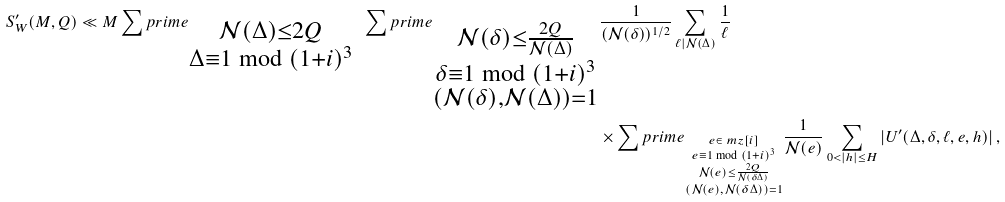Convert formula to latex. <formula><loc_0><loc_0><loc_500><loc_500>S ^ { \prime } _ { W } ( M , Q ) \ll M \sum p r i m e _ { \substack { \mathcal { N } ( \Delta ) \leq 2 Q \\ \Delta \equiv 1 \bmod { ( 1 + i ) ^ { 3 } } } } \ \sum p r i m e _ { \substack { \mathcal { N } ( \delta ) \leq \frac { 2 Q } { \mathcal { N } ( \Delta ) } \\ \delta \equiv 1 \bmod { ( 1 + i ) ^ { 3 } } \\ ( \mathcal { N } ( \delta ) , \mathcal { N } ( \Delta ) ) = 1 } } & \frac { 1 } { ( \mathcal { N } ( \delta ) ) ^ { 1 / 2 } } \sum _ { \ell | \mathcal { N } ( \Delta ) } \frac { 1 } { \ell } \\ & \times \sum p r i m e _ { \substack { e \in \ m z [ i ] \\ e \equiv 1 \bmod { ( 1 + i ) ^ { 3 } } \\ \mathcal { N } ( e ) \leq \frac { 2 Q } { \mathcal { N } ( \delta \Delta ) } \\ ( \mathcal { N } ( e ) , \mathcal { N } ( \delta \Delta ) ) = 1 } } \frac { 1 } { \mathcal { N } ( e ) } \sum _ { 0 < | h | \leq H } \left | U ^ { \prime } ( \Delta , \delta , \ell , e , h ) \right | ,</formula> 